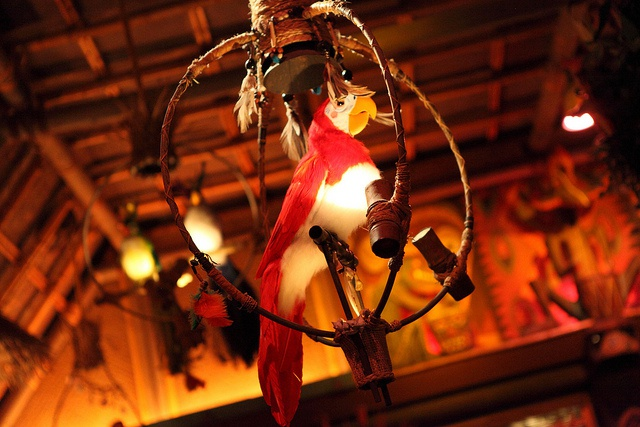Describe the objects in this image and their specific colors. I can see a bird in black, red, maroon, and orange tones in this image. 